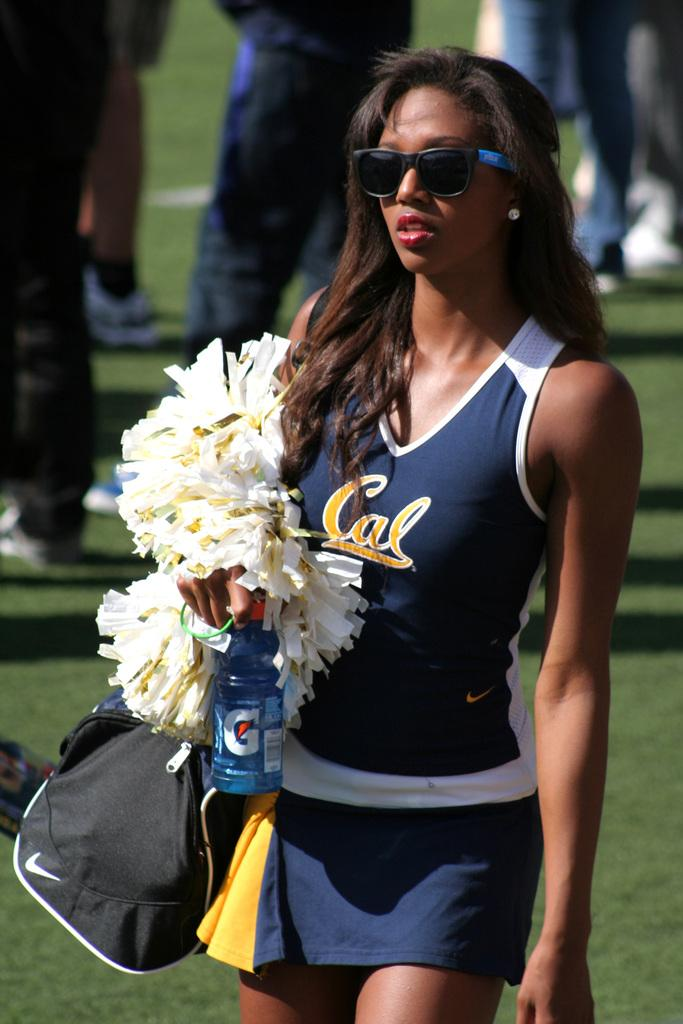<image>
Relay a brief, clear account of the picture shown. a cheerleader carries a Gatorade bottle and her pom poms 